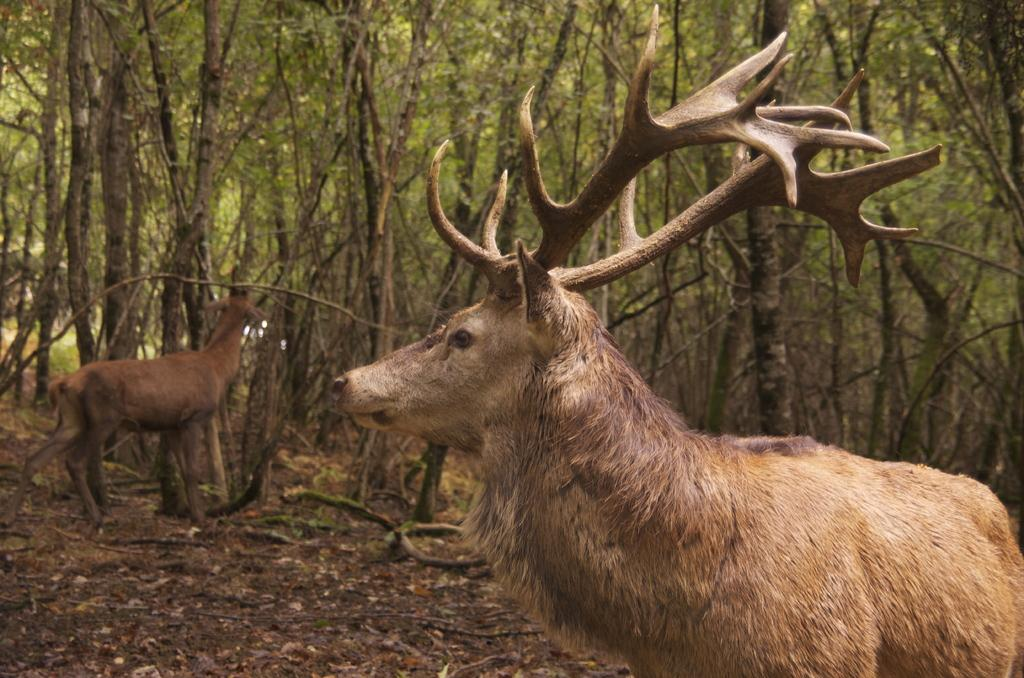How many deer are present in the image? There are 2 deer in the image. What can be seen in the background of the image? There are trees visible in the background of the image. What type of spark can be seen coming from the deer in the image? There is no spark present in the image; the deer are not emitting any sparks. 